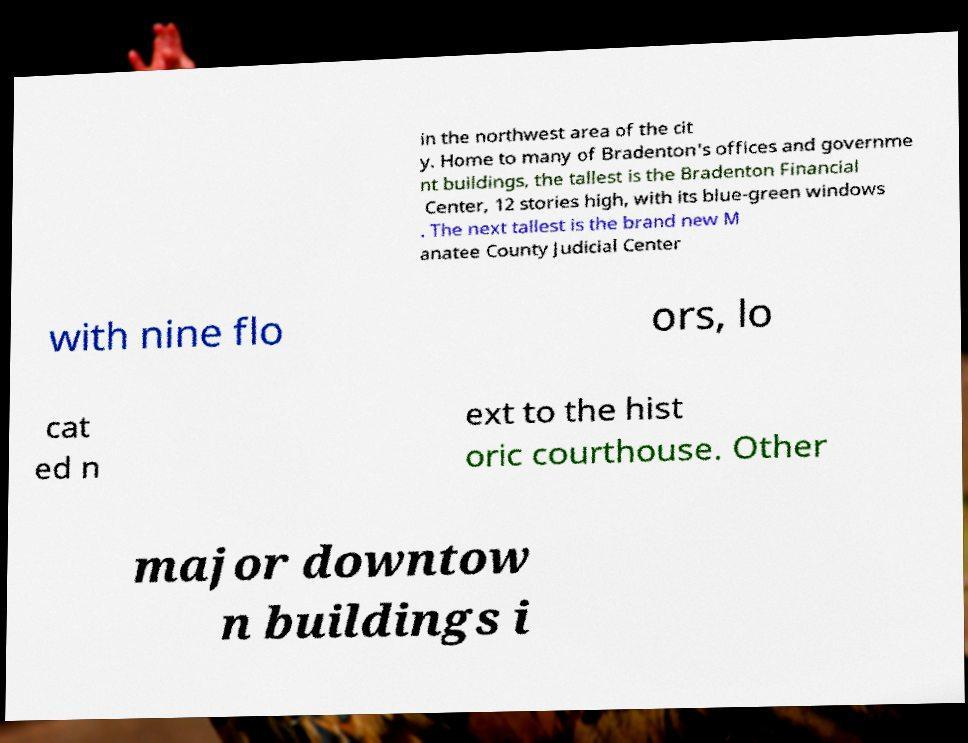What messages or text are displayed in this image? I need them in a readable, typed format. in the northwest area of the cit y. Home to many of Bradenton's offices and governme nt buildings, the tallest is the Bradenton Financial Center, 12 stories high, with its blue-green windows . The next tallest is the brand new M anatee County Judicial Center with nine flo ors, lo cat ed n ext to the hist oric courthouse. Other major downtow n buildings i 